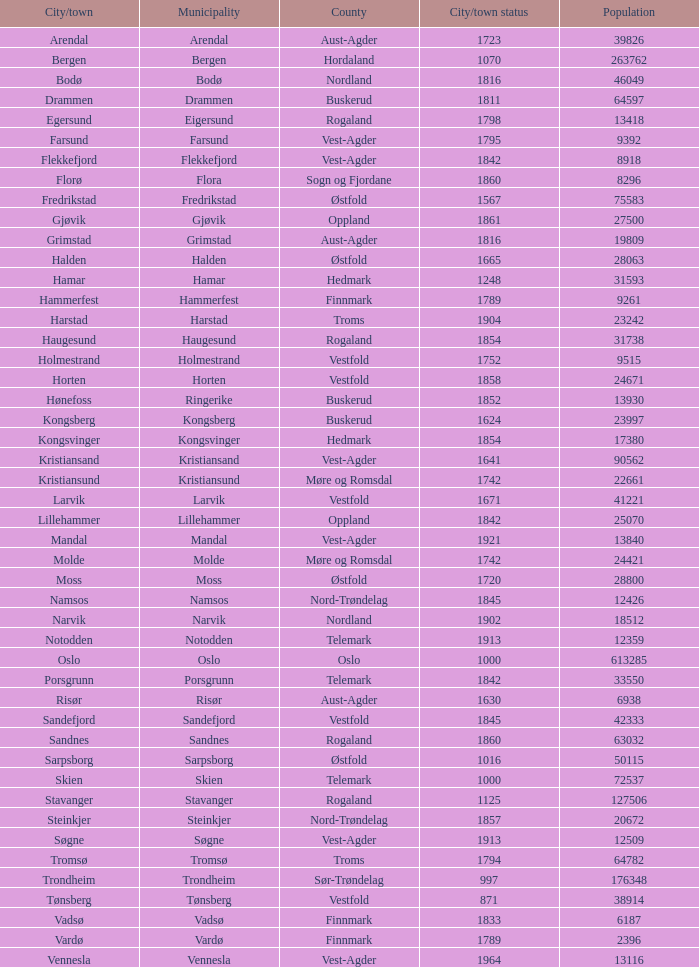What is the county where the city of halden resides? Østfold. Could you parse the entire table? {'header': ['City/town', 'Municipality', 'County', 'City/town status', 'Population'], 'rows': [['Arendal', 'Arendal', 'Aust-Agder', '1723', '39826'], ['Bergen', 'Bergen', 'Hordaland', '1070', '263762'], ['Bodø', 'Bodø', 'Nordland', '1816', '46049'], ['Drammen', 'Drammen', 'Buskerud', '1811', '64597'], ['Egersund', 'Eigersund', 'Rogaland', '1798', '13418'], ['Farsund', 'Farsund', 'Vest-Agder', '1795', '9392'], ['Flekkefjord', 'Flekkefjord', 'Vest-Agder', '1842', '8918'], ['Florø', 'Flora', 'Sogn og Fjordane', '1860', '8296'], ['Fredrikstad', 'Fredrikstad', 'Østfold', '1567', '75583'], ['Gjøvik', 'Gjøvik', 'Oppland', '1861', '27500'], ['Grimstad', 'Grimstad', 'Aust-Agder', '1816', '19809'], ['Halden', 'Halden', 'Østfold', '1665', '28063'], ['Hamar', 'Hamar', 'Hedmark', '1248', '31593'], ['Hammerfest', 'Hammerfest', 'Finnmark', '1789', '9261'], ['Harstad', 'Harstad', 'Troms', '1904', '23242'], ['Haugesund', 'Haugesund', 'Rogaland', '1854', '31738'], ['Holmestrand', 'Holmestrand', 'Vestfold', '1752', '9515'], ['Horten', 'Horten', 'Vestfold', '1858', '24671'], ['Hønefoss', 'Ringerike', 'Buskerud', '1852', '13930'], ['Kongsberg', 'Kongsberg', 'Buskerud', '1624', '23997'], ['Kongsvinger', 'Kongsvinger', 'Hedmark', '1854', '17380'], ['Kristiansand', 'Kristiansand', 'Vest-Agder', '1641', '90562'], ['Kristiansund', 'Kristiansund', 'Møre og Romsdal', '1742', '22661'], ['Larvik', 'Larvik', 'Vestfold', '1671', '41221'], ['Lillehammer', 'Lillehammer', 'Oppland', '1842', '25070'], ['Mandal', 'Mandal', 'Vest-Agder', '1921', '13840'], ['Molde', 'Molde', 'Møre og Romsdal', '1742', '24421'], ['Moss', 'Moss', 'Østfold', '1720', '28800'], ['Namsos', 'Namsos', 'Nord-Trøndelag', '1845', '12426'], ['Narvik', 'Narvik', 'Nordland', '1902', '18512'], ['Notodden', 'Notodden', 'Telemark', '1913', '12359'], ['Oslo', 'Oslo', 'Oslo', '1000', '613285'], ['Porsgrunn', 'Porsgrunn', 'Telemark', '1842', '33550'], ['Risør', 'Risør', 'Aust-Agder', '1630', '6938'], ['Sandefjord', 'Sandefjord', 'Vestfold', '1845', '42333'], ['Sandnes', 'Sandnes', 'Rogaland', '1860', '63032'], ['Sarpsborg', 'Sarpsborg', 'Østfold', '1016', '50115'], ['Skien', 'Skien', 'Telemark', '1000', '72537'], ['Stavanger', 'Stavanger', 'Rogaland', '1125', '127506'], ['Steinkjer', 'Steinkjer', 'Nord-Trøndelag', '1857', '20672'], ['Søgne', 'Søgne', 'Vest-Agder', '1913', '12509'], ['Tromsø', 'Tromsø', 'Troms', '1794', '64782'], ['Trondheim', 'Trondheim', 'Sør-Trøndelag', '997', '176348'], ['Tønsberg', 'Tønsberg', 'Vestfold', '871', '38914'], ['Vadsø', 'Vadsø', 'Finnmark', '1833', '6187'], ['Vardø', 'Vardø', 'Finnmark', '1789', '2396'], ['Vennesla', 'Vennesla', 'Vest-Agder', '1964', '13116']]} 